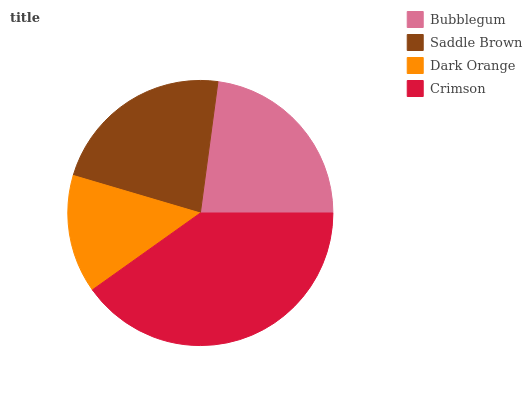Is Dark Orange the minimum?
Answer yes or no. Yes. Is Crimson the maximum?
Answer yes or no. Yes. Is Saddle Brown the minimum?
Answer yes or no. No. Is Saddle Brown the maximum?
Answer yes or no. No. Is Bubblegum greater than Saddle Brown?
Answer yes or no. Yes. Is Saddle Brown less than Bubblegum?
Answer yes or no. Yes. Is Saddle Brown greater than Bubblegum?
Answer yes or no. No. Is Bubblegum less than Saddle Brown?
Answer yes or no. No. Is Bubblegum the high median?
Answer yes or no. Yes. Is Saddle Brown the low median?
Answer yes or no. Yes. Is Saddle Brown the high median?
Answer yes or no. No. Is Crimson the low median?
Answer yes or no. No. 